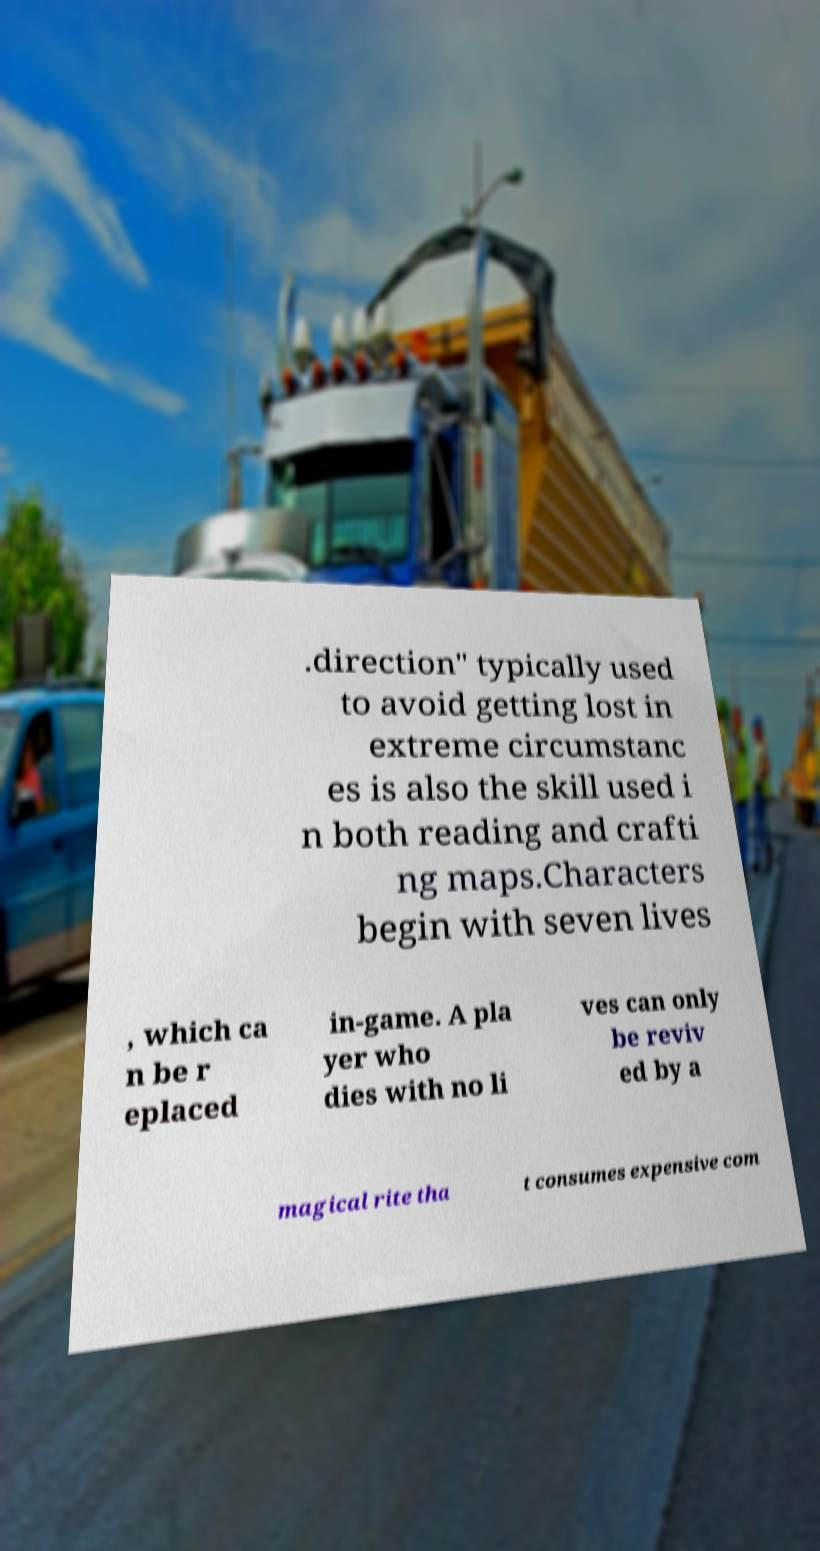Please identify and transcribe the text found in this image. .direction" typically used to avoid getting lost in extreme circumstanc es is also the skill used i n both reading and crafti ng maps.Characters begin with seven lives , which ca n be r eplaced in-game. A pla yer who dies with no li ves can only be reviv ed by a magical rite tha t consumes expensive com 